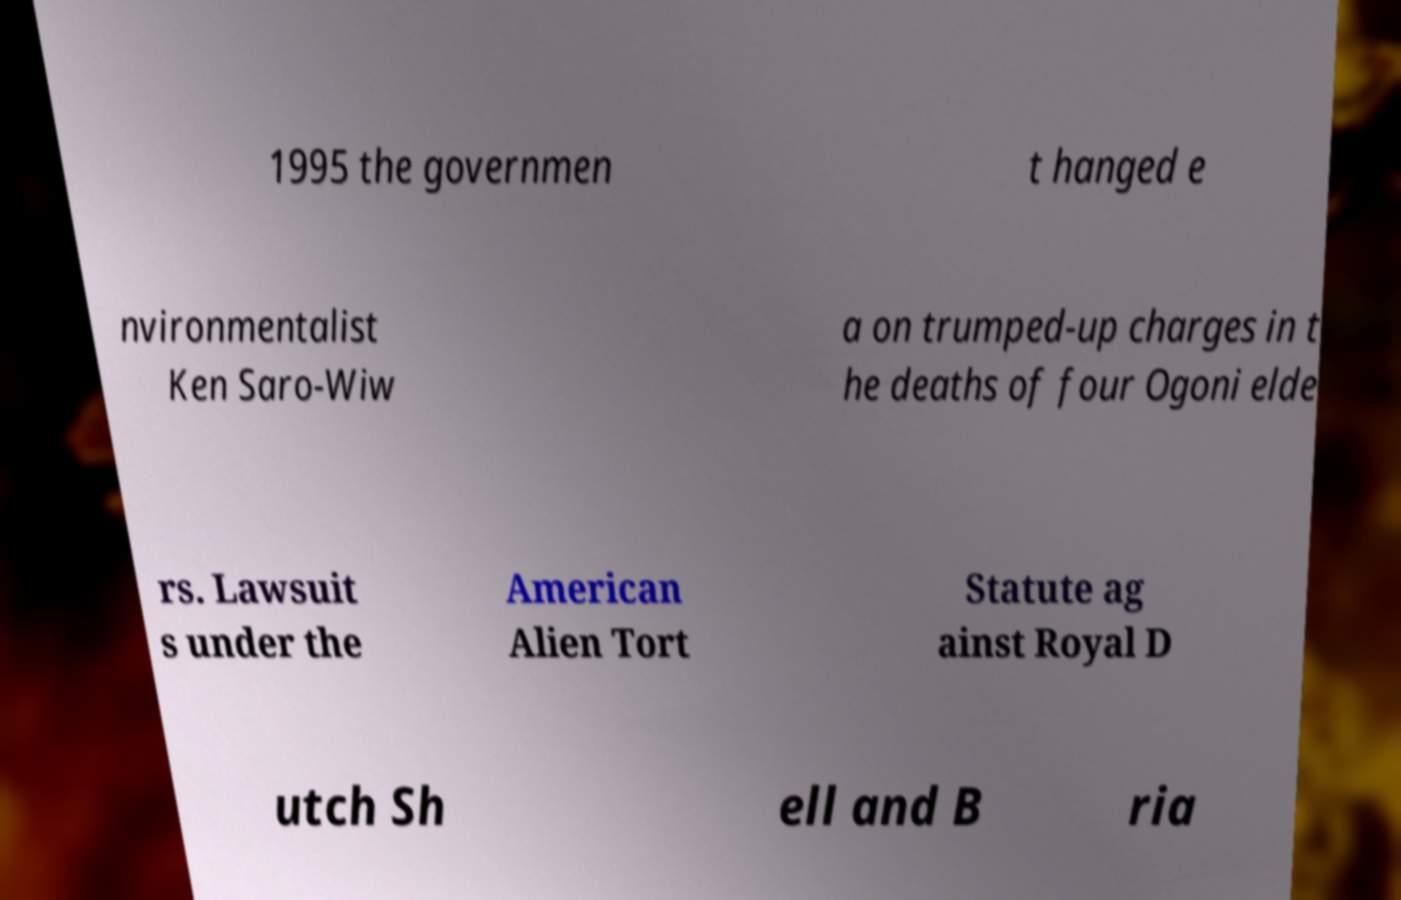Could you assist in decoding the text presented in this image and type it out clearly? 1995 the governmen t hanged e nvironmentalist Ken Saro-Wiw a on trumped-up charges in t he deaths of four Ogoni elde rs. Lawsuit s under the American Alien Tort Statute ag ainst Royal D utch Sh ell and B ria 